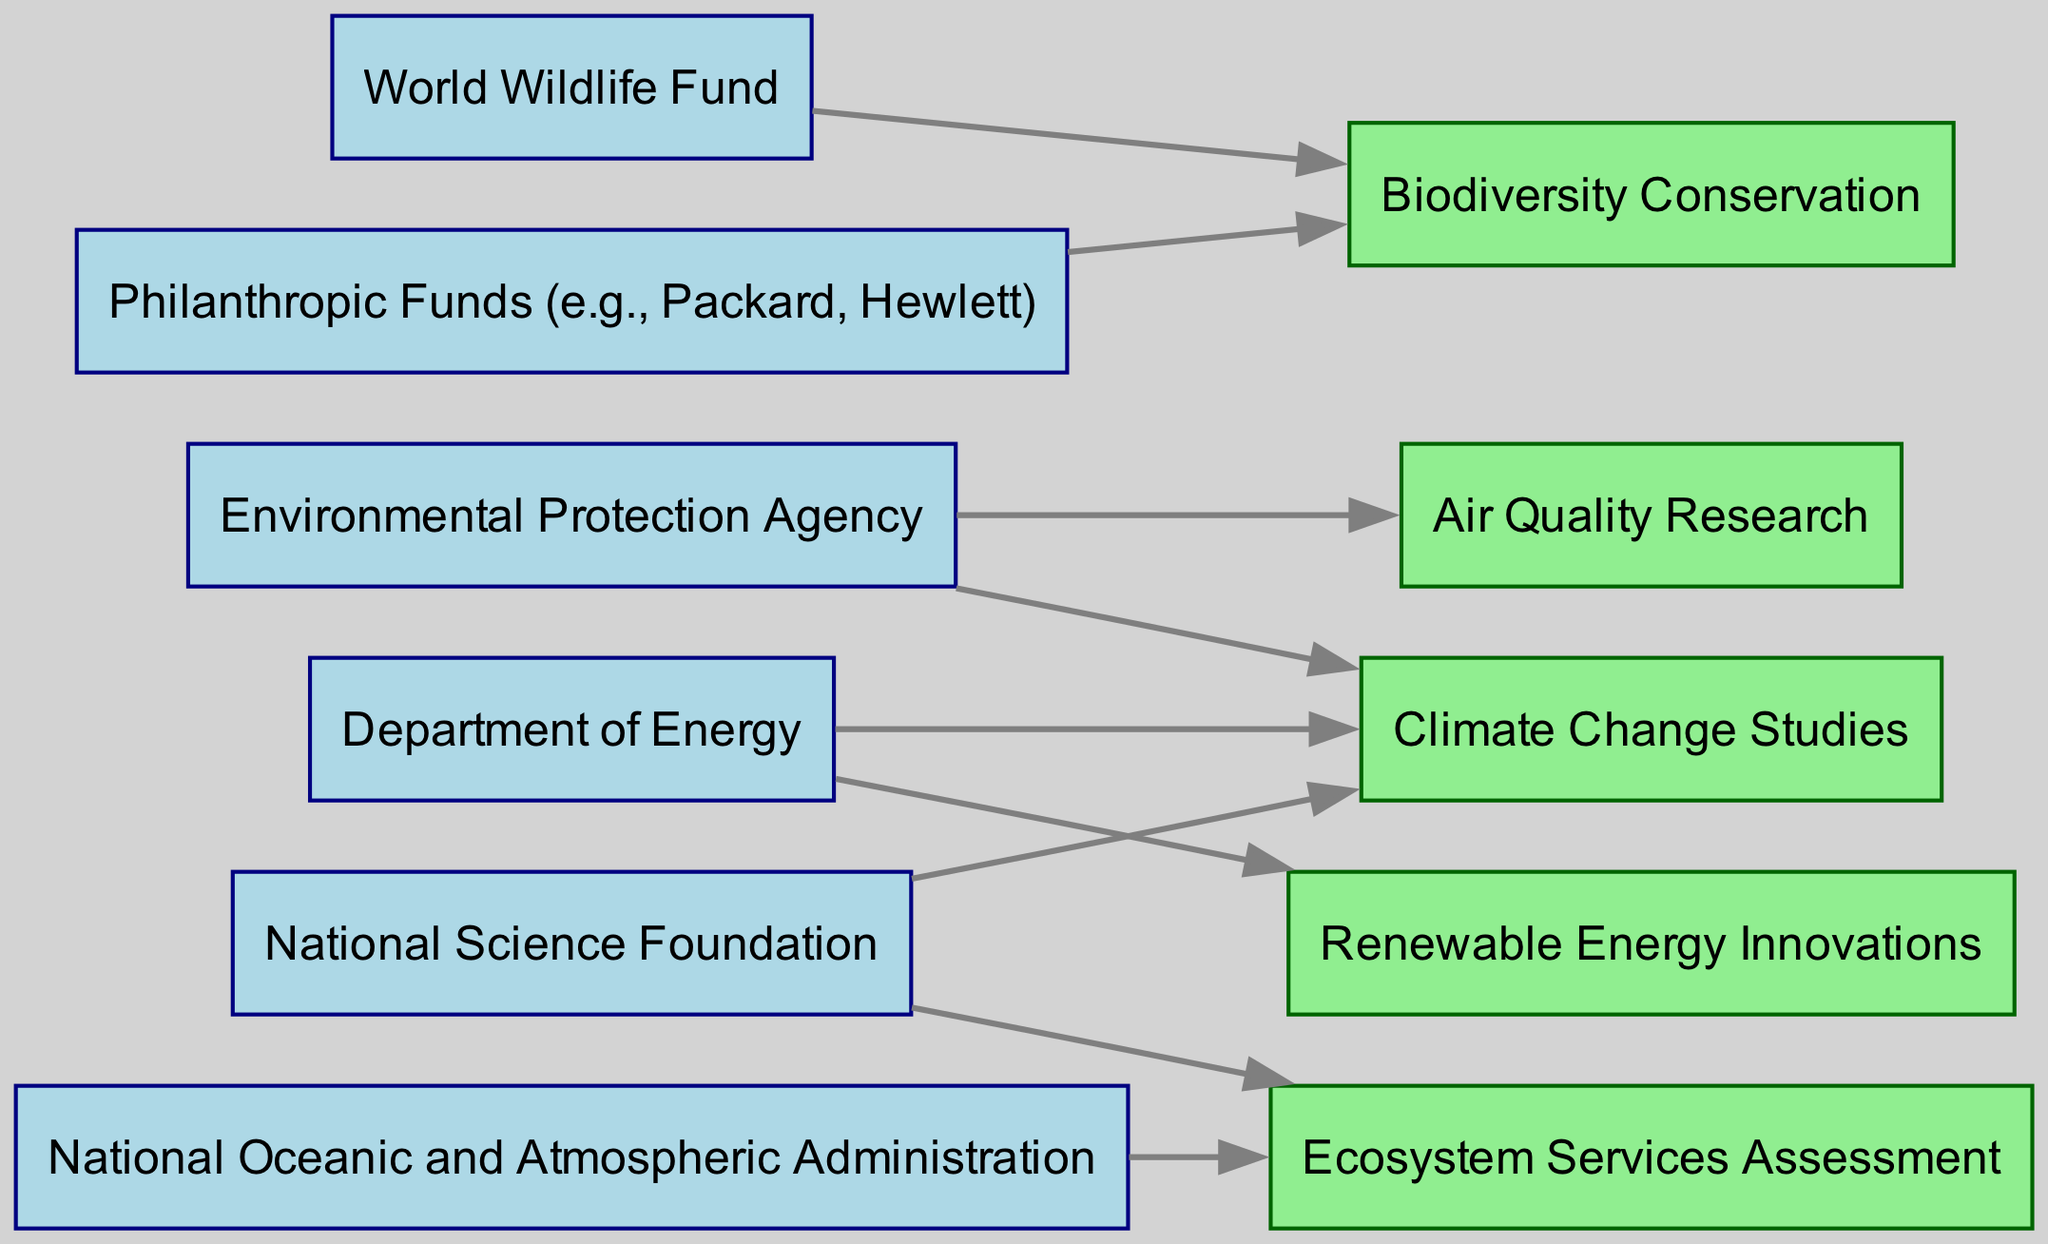What are the funding sources for biodiversity conservation? The nodes linked to the "Biodiversity Conservation" research area are "WWF" and "PHH," indicating that these are the funding sources for this area.
Answer: WWF, PHH How many research areas are targeted by NSF? The NSF node has edges leading to two research areas: "Climate Change Studies" and "Ecosystem Services Assessment." Thus, NSF targets 2 research areas.
Answer: 2 Which grant agency funds both air quality and climate change research? The "EPA" node connects to "Air Quality Research," and there is an additional edge from "EPA" to "Climate Change Studies," indicating that EPA funds both.
Answer: EPA Which funding source exclusively supports renewable energy? The "Department of Energy" (DOE) node only has an outgoing edge to the "Renewable Energy Innovations" area, indicating exclusive support.
Answer: DOE What is the total number of edges in the diagram? By counting all connecting lines (edges) from each funding source to their respective research areas, there are a total of 8 edges present.
Answer: 8 How many funding sources contribute to climate change studies? The "Climate Change Studies" area is sourced from three nodes: "NSF," "EPA," and "DOE," indicating that there are 3 contributors.
Answer: 3 Are there any funding sources that support both ecosystem services and climate change? Upon reviewing the edges, "NSF" connects to both "Ecosystem Services Assessment" and "Climate Change Studies," indicating it supports both areas.
Answer: NSF Which research area has the most diverse funding sources? "Biodiversity Conservation" has the most sources with two funding agencies linked (WWF and PHH), while other areas have at most 2; therefore, it is the most diverse.
Answer: Biodiversity Conservation 